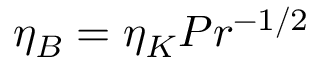Convert formula to latex. <formula><loc_0><loc_0><loc_500><loc_500>\eta _ { B } = \eta _ { K } P r ^ { - 1 / 2 }</formula> 